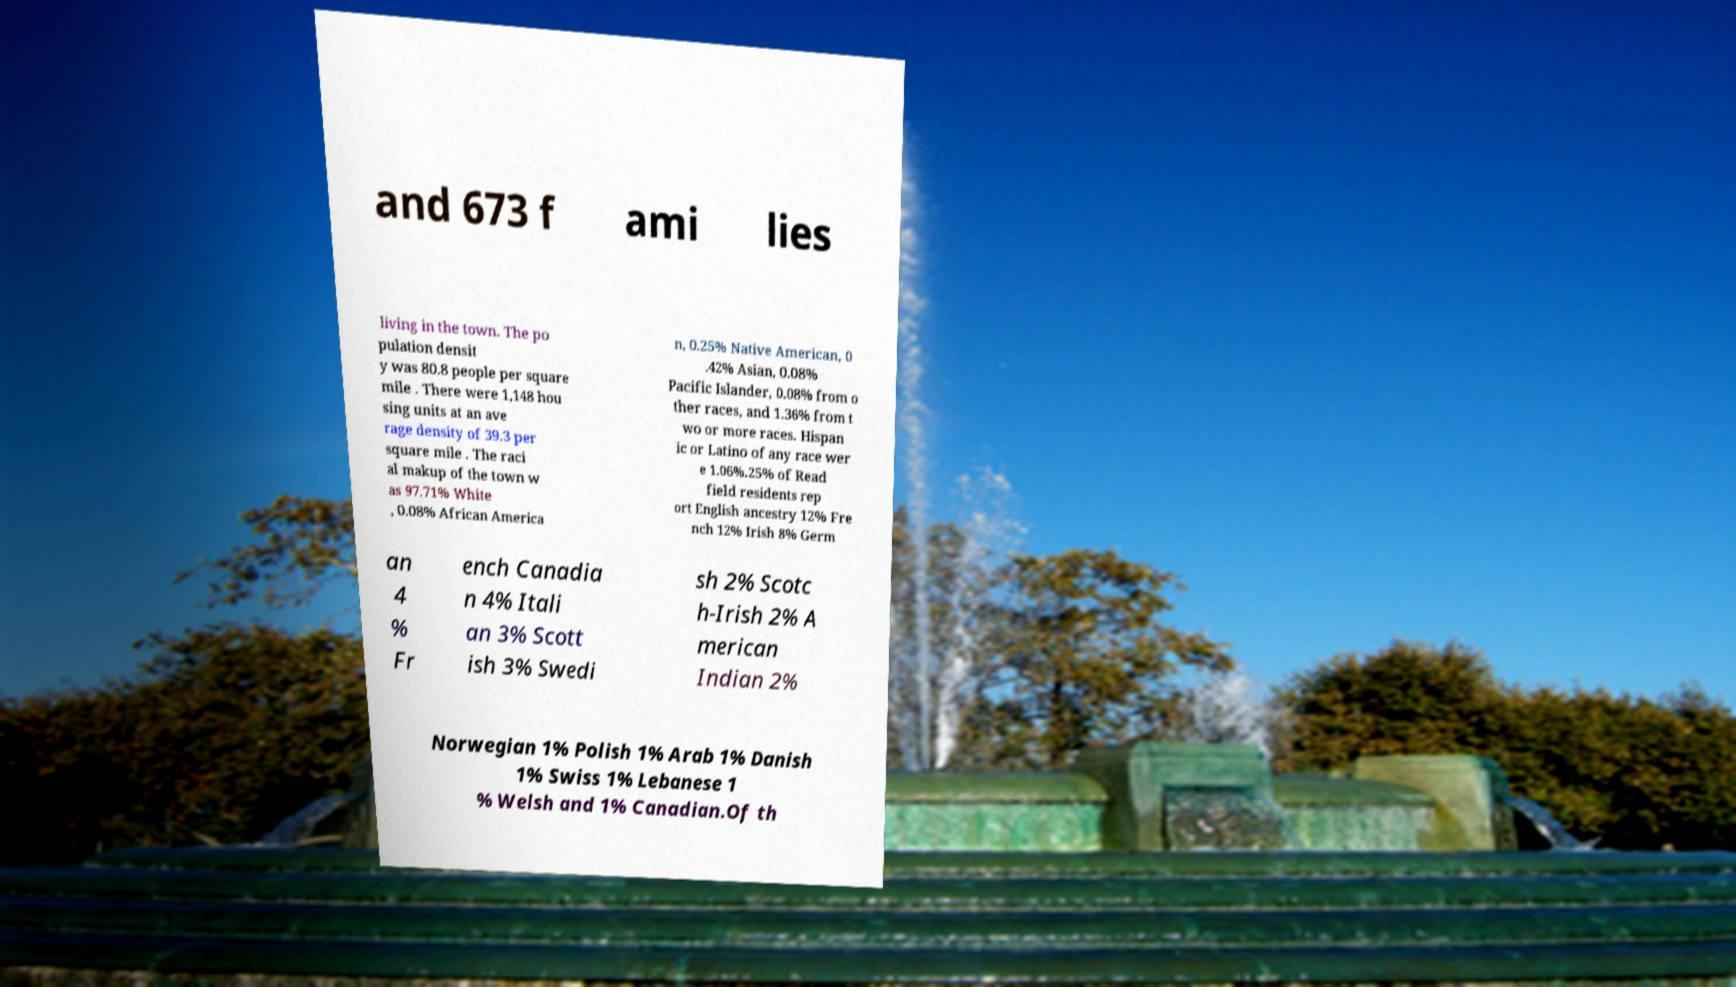Could you extract and type out the text from this image? and 673 f ami lies living in the town. The po pulation densit y was 80.8 people per square mile . There were 1,148 hou sing units at an ave rage density of 39.3 per square mile . The raci al makup of the town w as 97.71% White , 0.08% African America n, 0.25% Native American, 0 .42% Asian, 0.08% Pacific Islander, 0.08% from o ther races, and 1.36% from t wo or more races. Hispan ic or Latino of any race wer e 1.06%.25% of Read field residents rep ort English ancestry 12% Fre nch 12% Irish 8% Germ an 4 % Fr ench Canadia n 4% Itali an 3% Scott ish 3% Swedi sh 2% Scotc h-Irish 2% A merican Indian 2% Norwegian 1% Polish 1% Arab 1% Danish 1% Swiss 1% Lebanese 1 % Welsh and 1% Canadian.Of th 